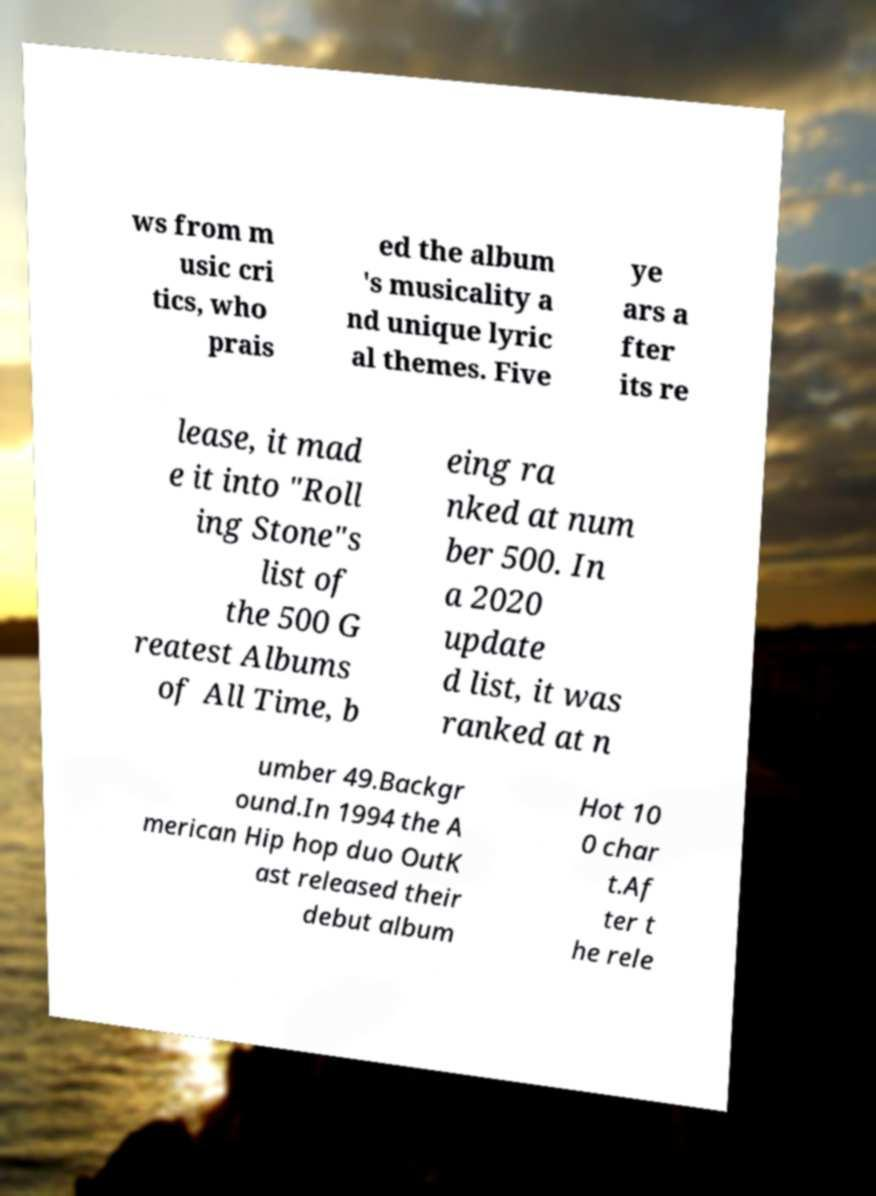Could you assist in decoding the text presented in this image and type it out clearly? ws from m usic cri tics, who prais ed the album 's musicality a nd unique lyric al themes. Five ye ars a fter its re lease, it mad e it into "Roll ing Stone"s list of the 500 G reatest Albums of All Time, b eing ra nked at num ber 500. In a 2020 update d list, it was ranked at n umber 49.Backgr ound.In 1994 the A merican Hip hop duo OutK ast released their debut album Hot 10 0 char t.Af ter t he rele 